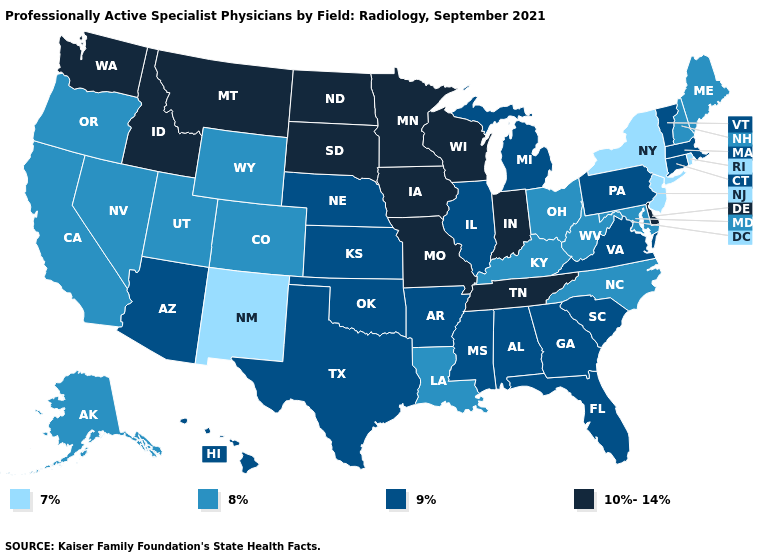Does Illinois have the lowest value in the MidWest?
Write a very short answer. No. Name the states that have a value in the range 7%?
Answer briefly. New Jersey, New Mexico, New York, Rhode Island. Does Vermont have a lower value than Louisiana?
Be succinct. No. Does South Dakota have the highest value in the USA?
Give a very brief answer. Yes. Does Indiana have the highest value in the MidWest?
Short answer required. Yes. What is the value of New Hampshire?
Keep it brief. 8%. Does Tennessee have the highest value in the South?
Concise answer only. Yes. Does West Virginia have the highest value in the USA?
Quick response, please. No. Which states have the lowest value in the USA?
Short answer required. New Jersey, New Mexico, New York, Rhode Island. Which states hav the highest value in the West?
Give a very brief answer. Idaho, Montana, Washington. Name the states that have a value in the range 8%?
Short answer required. Alaska, California, Colorado, Kentucky, Louisiana, Maine, Maryland, Nevada, New Hampshire, North Carolina, Ohio, Oregon, Utah, West Virginia, Wyoming. Does the first symbol in the legend represent the smallest category?
Give a very brief answer. Yes. Does the first symbol in the legend represent the smallest category?
Write a very short answer. Yes. Name the states that have a value in the range 9%?
Concise answer only. Alabama, Arizona, Arkansas, Connecticut, Florida, Georgia, Hawaii, Illinois, Kansas, Massachusetts, Michigan, Mississippi, Nebraska, Oklahoma, Pennsylvania, South Carolina, Texas, Vermont, Virginia. Among the states that border North Dakota , which have the highest value?
Quick response, please. Minnesota, Montana, South Dakota. 